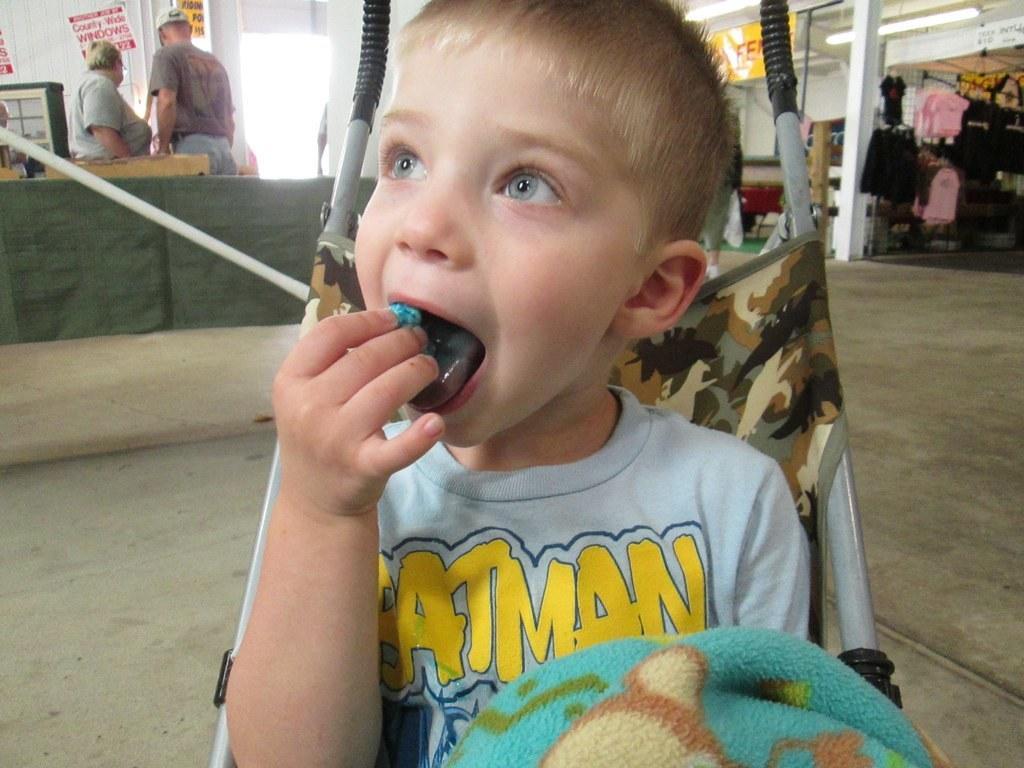Could you give a brief overview of what you see in this image? In this image we can see a child sitting on a stroller. In the back we can see few people. Also there are posters. On the right side there are dresses hanged. Also there is a pillar. And there is light. Near to the child we can see a cloth. 